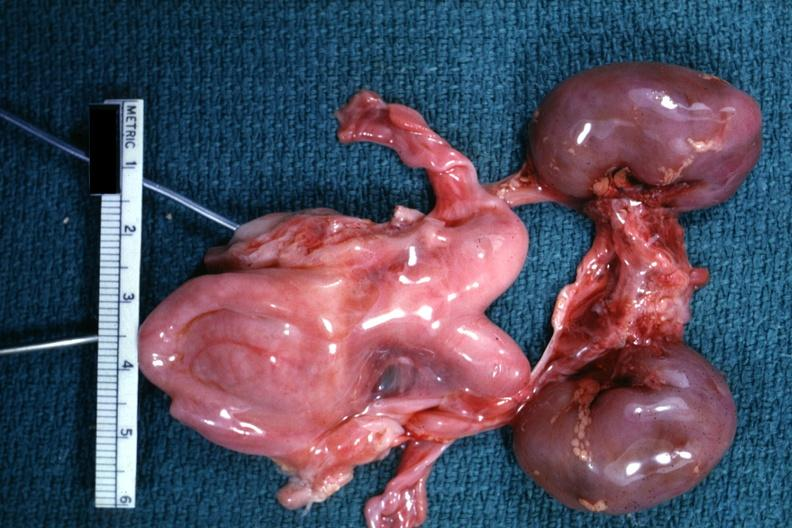what does this image show?
Answer the question using a single word or phrase. Infant organs clearly shown lesion 